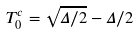<formula> <loc_0><loc_0><loc_500><loc_500>T _ { 0 } ^ { c } = \sqrt { \Delta / 2 } - \Delta / 2</formula> 